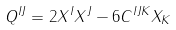<formula> <loc_0><loc_0><loc_500><loc_500>Q ^ { I J } = 2 X ^ { I } X ^ { J } - 6 C ^ { I J K } X _ { K }</formula> 